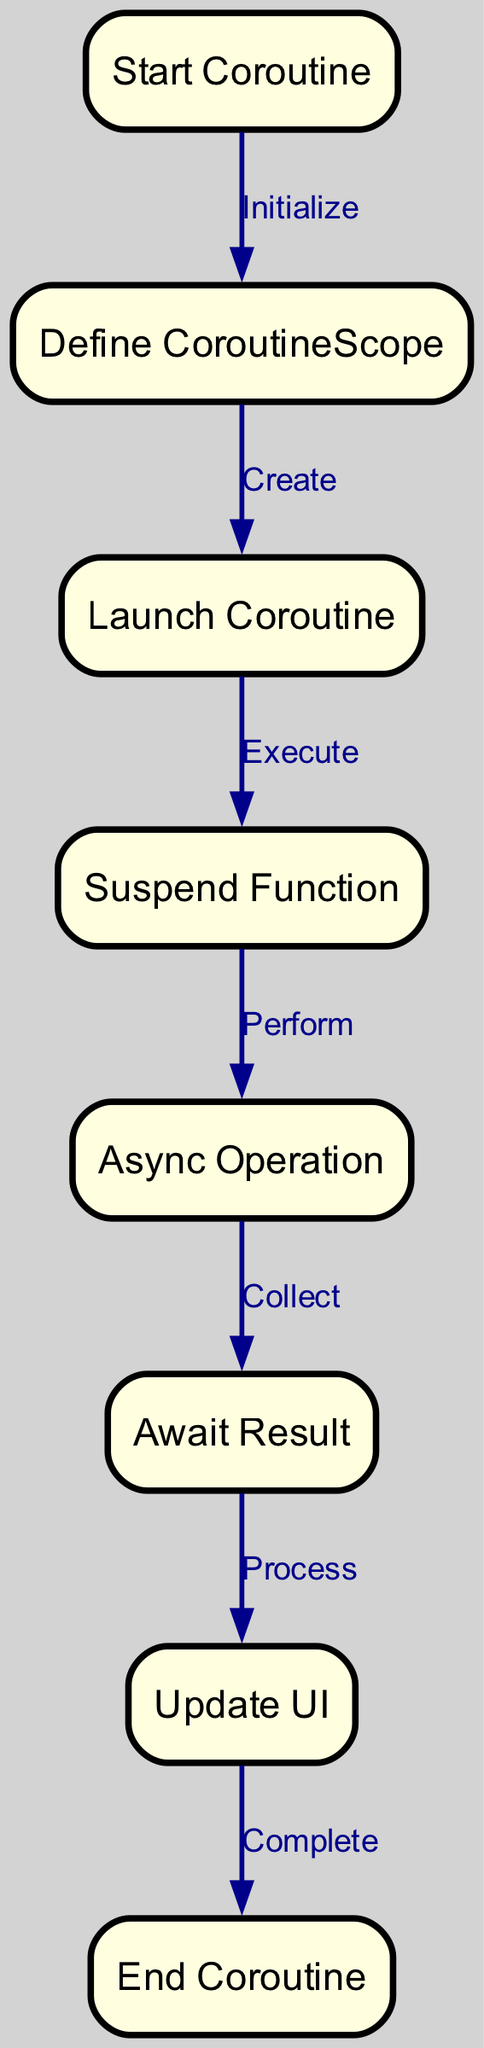What is the first step in the flowchart? The flowchart begins at the "Start Coroutine" node, indicating that this is the first step in the asynchronous programming process using Kotlin coroutines.
Answer: Start Coroutine How many nodes are present in the diagram? The diagram contains a total of eight nodes, which are "Start Coroutine," "Define CoroutineScope," "Launch Coroutine," "Suspend Function," "Async Operation," "Await Result," "Update UI," and "End Coroutine."
Answer: Eight What type of operation is performed after the "Suspend Function" node? After the "Suspend Function" node is executed, the next operation indicated in the flowchart is "Async Operation," which signifies the beginning of an asynchronous task.
Answer: Async Operation What is the connection between "Await Result" and "Update UI"? The "Await Result" node leads to the "Update UI" node, meaning that once the result is awaited, the algorithm moves to the step where the UI is updated based on the received result.
Answer: Process What is the last step in the flowchart? The final step in the flowchart is "End Coroutine," which indicates the completion of the coroutine execution process.
Answer: End Coroutine What is the total number of edges connecting the nodes? There are a total of seven edges in the flowchart, connecting the various nodes to illustrate the flow of operations in Kotlin coroutines.
Answer: Seven Which node is directly linked to "Launch Coroutine"? The "Launch Coroutine" node is directly linked to the "Suspend Function" node, indicating the sequence in which these steps occur during coroutine execution.
Answer: Suspend Function What performs the operations after launching the coroutine? After launching the coroutine, the operations are performed by the "Suspend Function," which signifies that the coroutine can suspend its execution.
Answer: Suspend Function What is the role of the "Define CoroutineScope"? The "Define CoroutineScope" node establishes the scope in which the coroutine will operate, serving as a context for launching asynchronous tasks.
Answer: CoroutineScope 